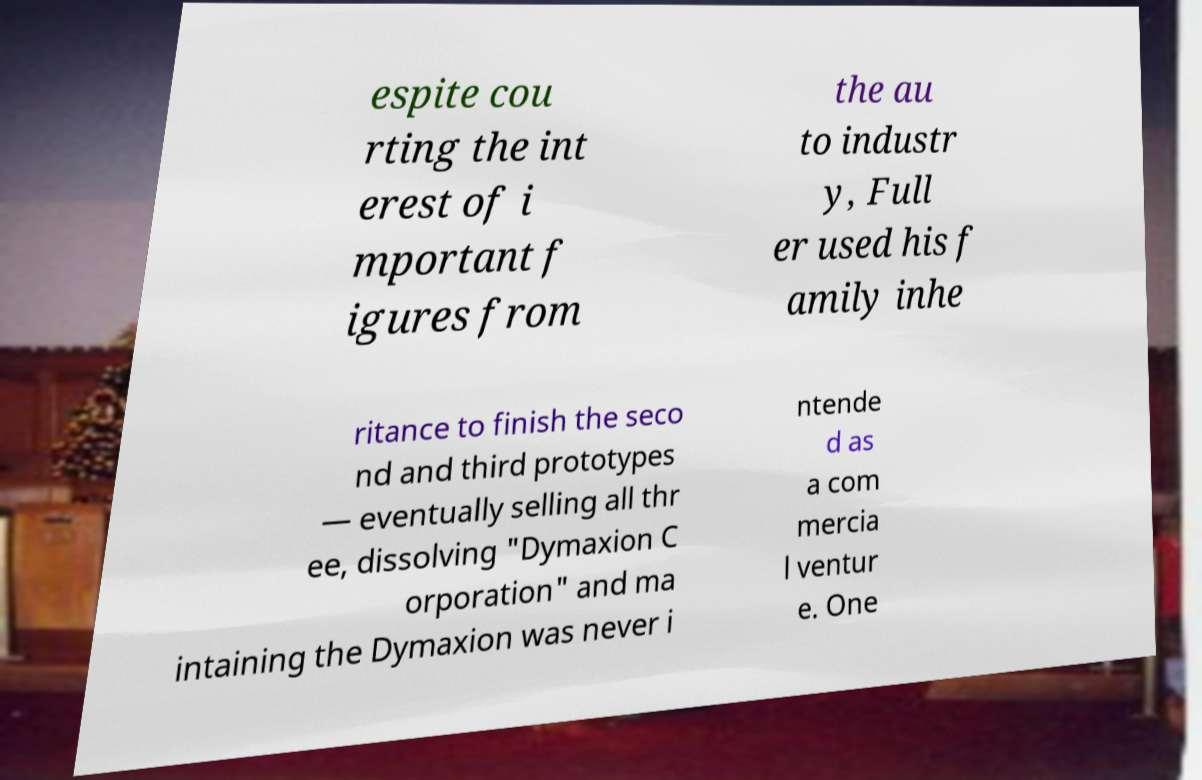Please read and relay the text visible in this image. What does it say? espite cou rting the int erest of i mportant f igures from the au to industr y, Full er used his f amily inhe ritance to finish the seco nd and third prototypes — eventually selling all thr ee, dissolving "Dymaxion C orporation" and ma intaining the Dymaxion was never i ntende d as a com mercia l ventur e. One 